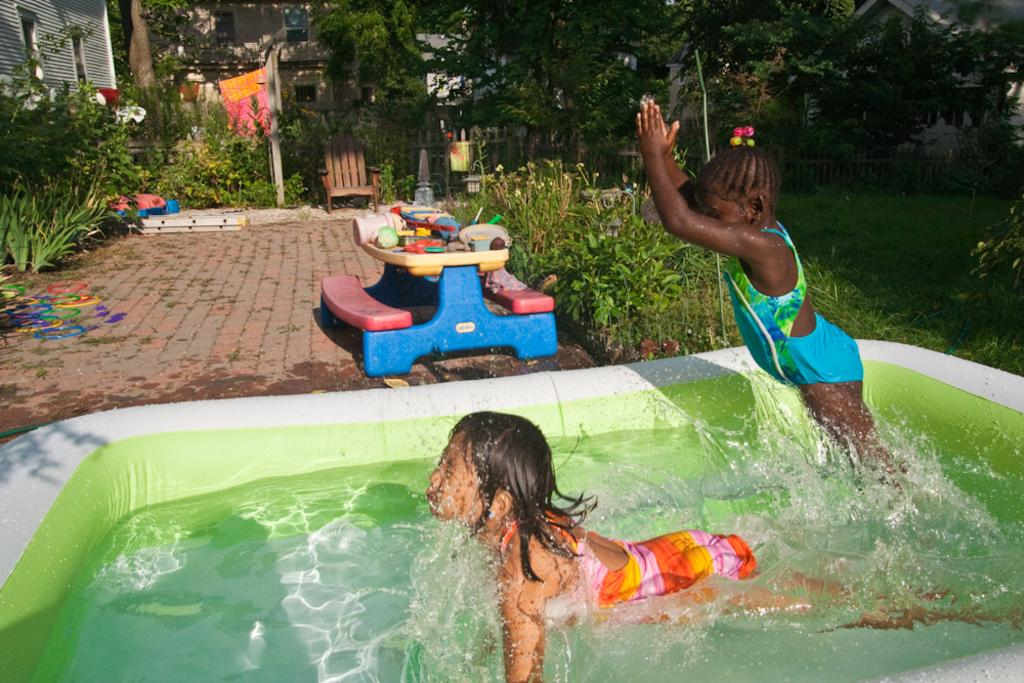How many kids are in the image? There are two kids in the image. What is one of the kids doing in the image? One kid is swimming in the water. What type of vegetation can be seen in the image? There are green color plants and trees in the image. What surface is visible in the image? There is a floor visible in the image. What type of vegetable is being used as a prop in the image? There is no vegetable present in the image, and therefore no such prop can be observed. 